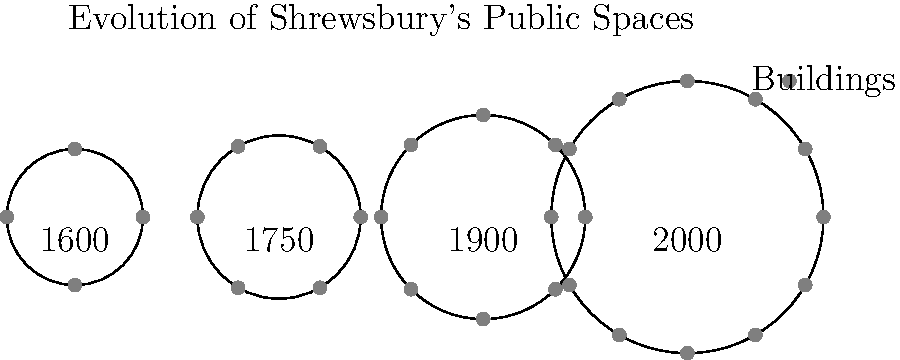Based on the simplified town layouts shown above, which represents the most significant change in Shrewsbury's public spaces, and what factors might have contributed to this transformation? To answer this question, we need to analyze the changes in Shrewsbury's layout over time:

1. 1600: The town is small with only 4 buildings around a central space.
2. 1750: There's a slight increase in size and number of buildings (6).
3. 1900: The town has grown further, with 8 buildings and a larger central area.
4. 2000: The most dramatic change is evident, with a much larger area and 12 buildings.

The most significant change appears to be between 1900 and 2000. Factors contributing to this transformation may include:

1. Population growth: More people required more housing and public spaces.
2. Industrialization: New economic activities may have led to urban expansion.
3. Transportation improvements: Better roads and railways could have connected Shrewsbury to other areas, spurring growth.
4. Urban planning: Deliberate efforts to create more public spaces and a more organized town layout.
5. Changing social needs: New requirements for education, healthcare, and leisure facilities.

This transformation likely reflects a shift from a small, medieval town structure to a modern urban layout with more diverse public spaces and functions.
Answer: 1900 to 2000; population growth, industrialization, improved transportation, urban planning, and changing social needs. 